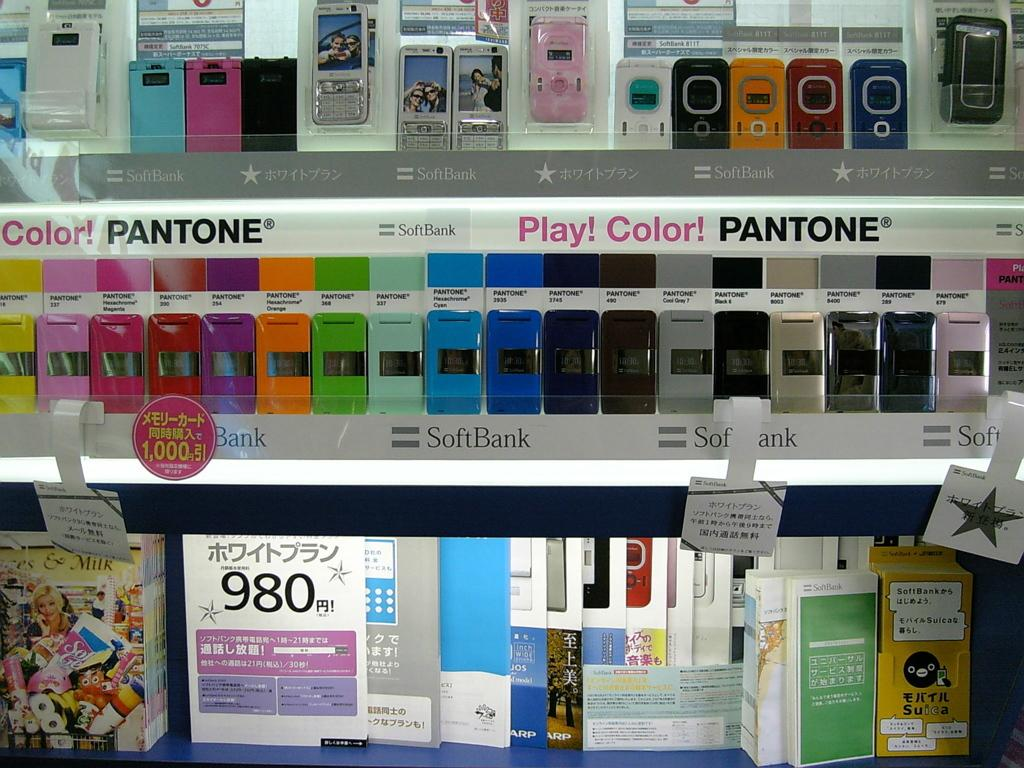What type of storage units are in the image? There are racks in the image. What can be found inside the racks? Electronic gadgets are present in the racks. Are there any additional decorative elements in the image? Yes, there are stickers visible in the image. What type of flooring can be seen in the image? There is no information about the flooring in the image. 